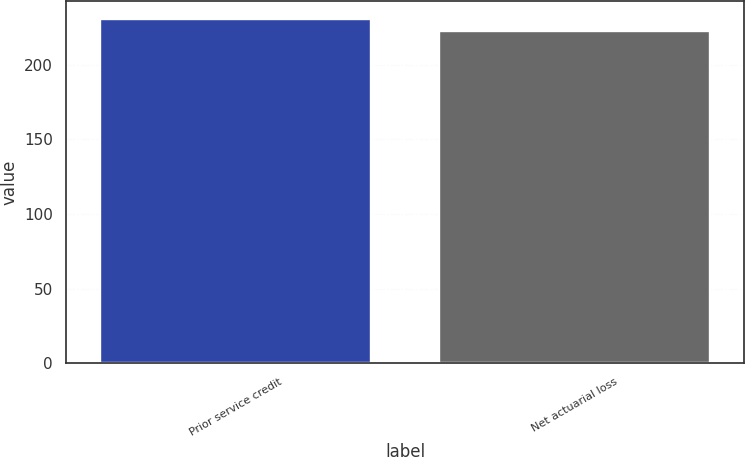Convert chart. <chart><loc_0><loc_0><loc_500><loc_500><bar_chart><fcel>Prior service credit<fcel>Net actuarial loss<nl><fcel>231<fcel>223<nl></chart> 